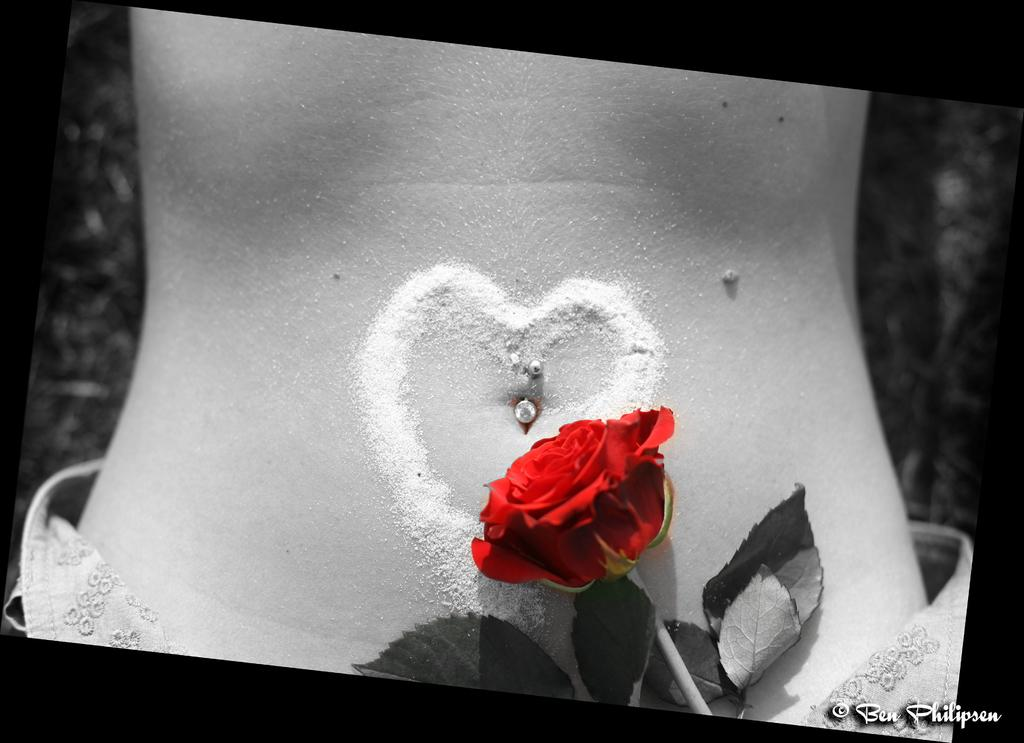What is the main subject of the image? There is a rose in the image. How is the rose positioned in the image? The rose is placed on a cardboard. What is the color scheme of the image? The image is in black and white color. What type of gold jewelry is the rose wearing in the image? There is no gold jewelry or any jewelry on the rose in the image. 